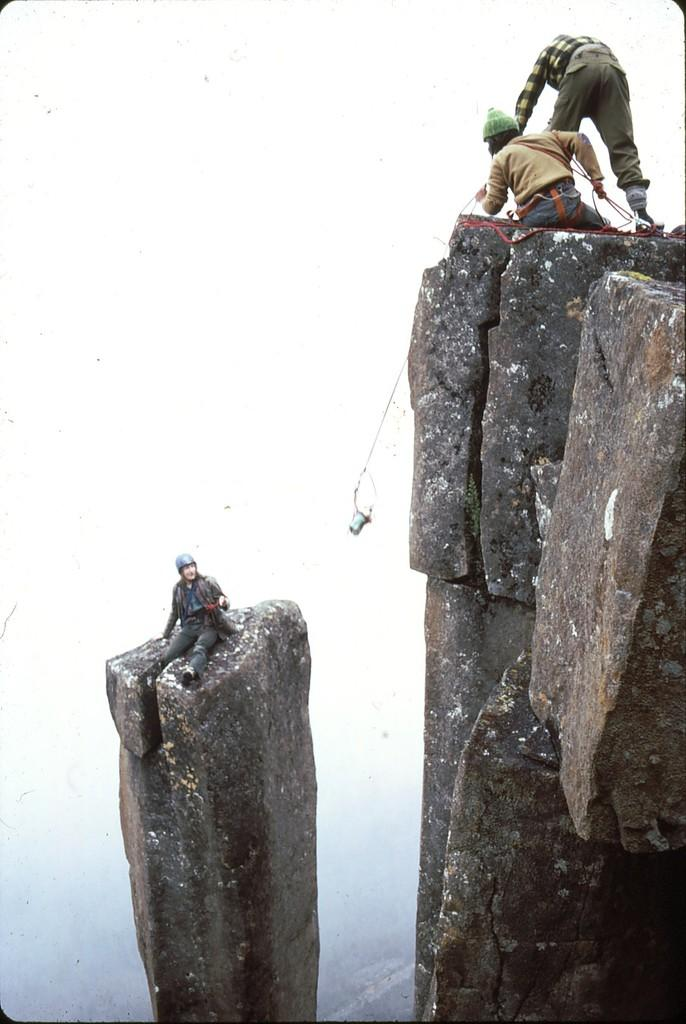How many people are in the image? There are three persons in the image. What is one person doing in the image? One person is sitting on a rock. What is the person sitting on the rock wearing? The person sitting on the rock is wearing a black dress. What can be seen in the background of the image? The sky is visible in the background of the image. What is the color of the sky in the image? The color of the sky in the image is white. What type of net can be seen in the image? There is no net present in the image. How does the zephyr affect the person sitting on the rock in the image? There is no mention of a zephyr or any wind in the image, so its effect cannot be determined. 